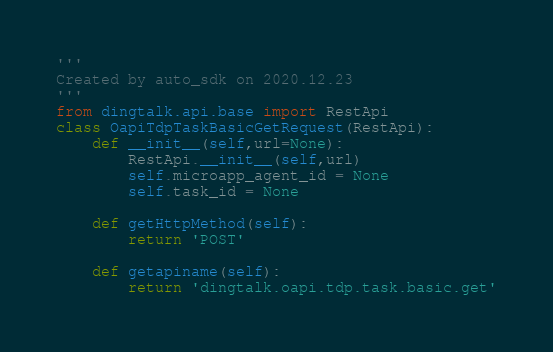<code> <loc_0><loc_0><loc_500><loc_500><_Python_>'''
Created by auto_sdk on 2020.12.23
'''
from dingtalk.api.base import RestApi
class OapiTdpTaskBasicGetRequest(RestApi):
	def __init__(self,url=None):
		RestApi.__init__(self,url)
		self.microapp_agent_id = None
		self.task_id = None

	def getHttpMethod(self):
		return 'POST'

	def getapiname(self):
		return 'dingtalk.oapi.tdp.task.basic.get'
</code> 